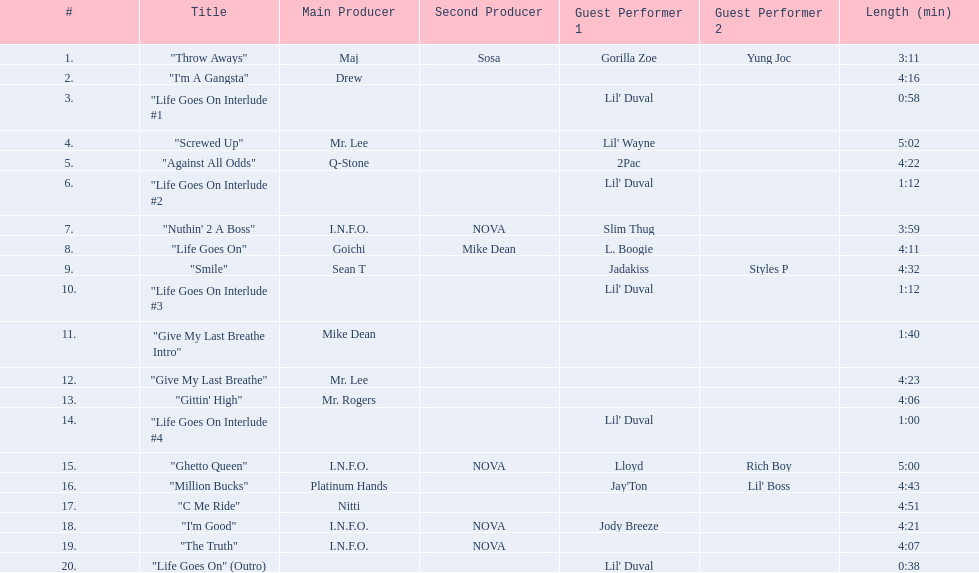What tracks appear on the album life goes on (trae album)? "Throw Aways", "I'm A Gangsta", "Life Goes On Interlude #1, "Screwed Up", "Against All Odds", "Life Goes On Interlude #2, "Nuthin' 2 A Boss", "Life Goes On", "Smile", "Life Goes On Interlude #3, "Give My Last Breathe Intro", "Give My Last Breathe", "Gittin' High", "Life Goes On Interlude #4, "Ghetto Queen", "Million Bucks", "C Me Ride", "I'm Good", "The Truth", "Life Goes On" (Outro). Which of these songs are at least 5 minutes long? "Screwed Up", "Ghetto Queen". Of these two songs over 5 minutes long, which is longer? "Screwed Up". How long is this track? 5:02. 